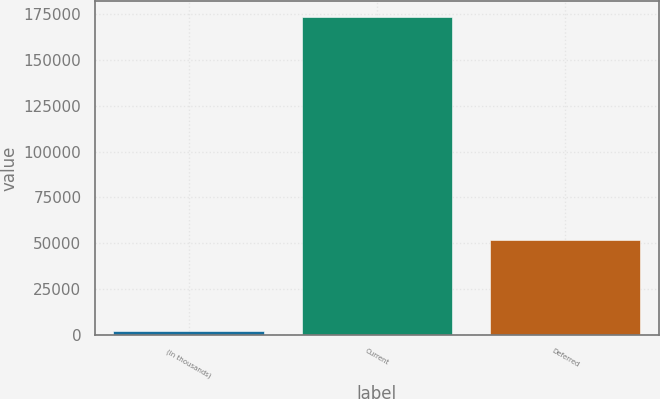Convert chart to OTSL. <chart><loc_0><loc_0><loc_500><loc_500><bar_chart><fcel>(In thousands)<fcel>Current<fcel>Deferred<nl><fcel>2013<fcel>173418<fcel>51475<nl></chart> 